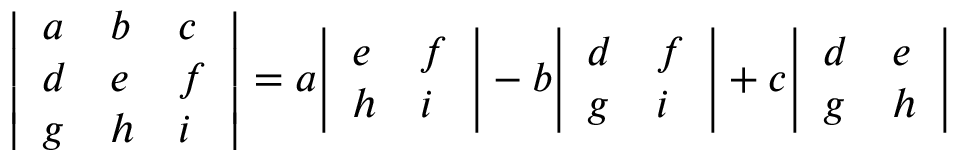<formula> <loc_0><loc_0><loc_500><loc_500>{ \left | \begin{array} { l l l } { a } & { b } & { c } \\ { d } & { e } & { f } \\ { g } & { h } & { i } \end{array} \right | } = a { \left | \begin{array} { l l } { e } & { f } \\ { h } & { i } \end{array} \right | } - b { \left | \begin{array} { l l } { d } & { f } \\ { g } & { i } \end{array} \right | } + c { \left | \begin{array} { l l } { d } & { e } \\ { g } & { h } \end{array} \right | }</formula> 